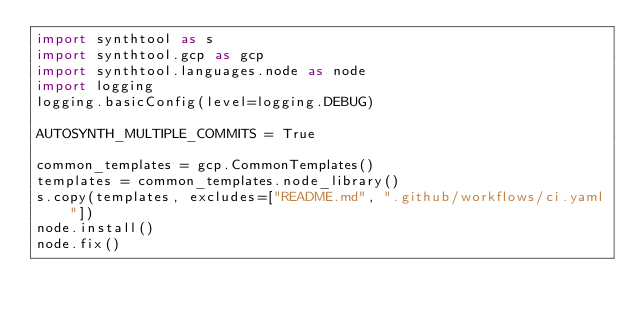<code> <loc_0><loc_0><loc_500><loc_500><_Python_>import synthtool as s
import synthtool.gcp as gcp
import synthtool.languages.node as node
import logging
logging.basicConfig(level=logging.DEBUG)

AUTOSYNTH_MULTIPLE_COMMITS = True

common_templates = gcp.CommonTemplates()
templates = common_templates.node_library()
s.copy(templates, excludes=["README.md", ".github/workflows/ci.yaml"])
node.install()
node.fix()
</code> 